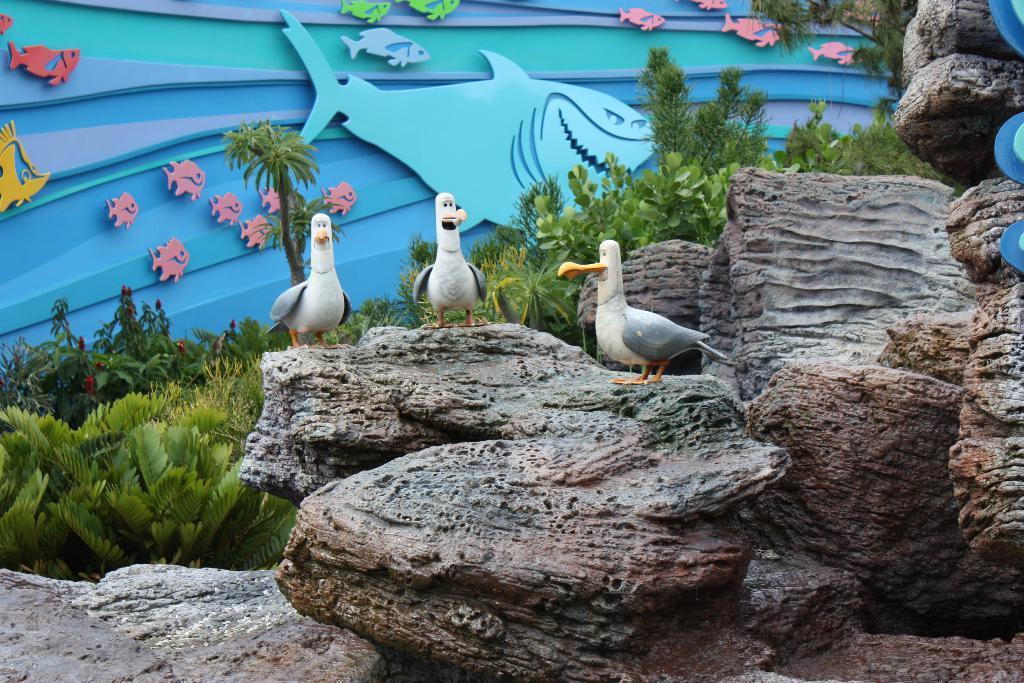Can you describe this image briefly? In this image we can see sculptures of birds and there are rocks. We can see plants. In the background there is a board and we can see fish carved on the board. 